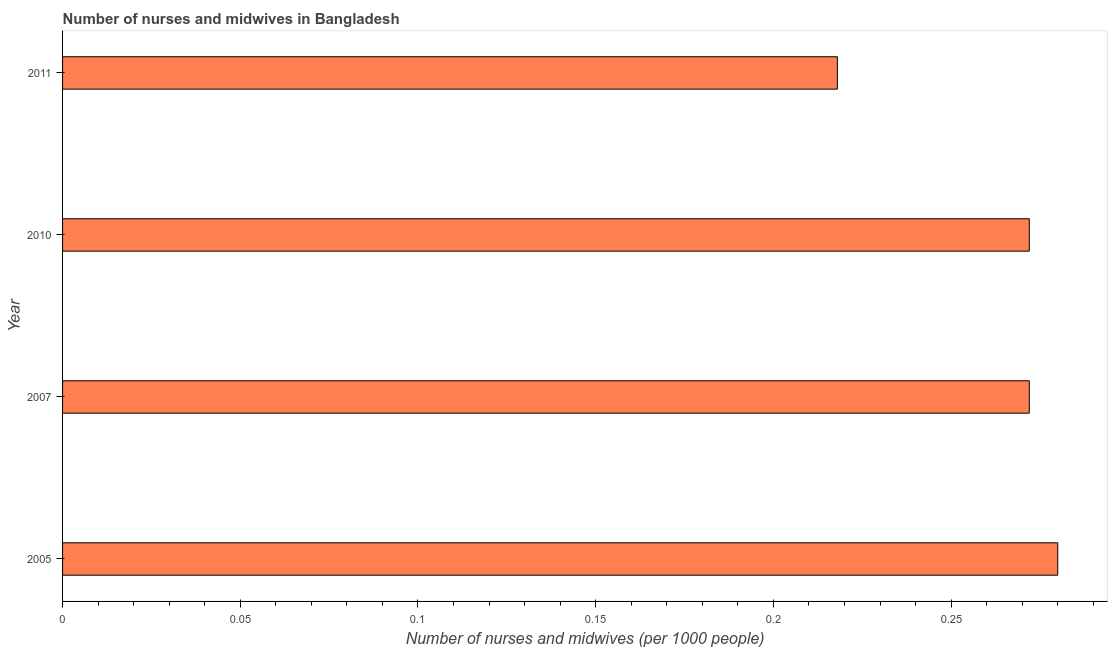Does the graph contain any zero values?
Offer a terse response. No. What is the title of the graph?
Your answer should be compact. Number of nurses and midwives in Bangladesh. What is the label or title of the X-axis?
Provide a short and direct response. Number of nurses and midwives (per 1000 people). What is the label or title of the Y-axis?
Give a very brief answer. Year. What is the number of nurses and midwives in 2007?
Your response must be concise. 0.27. Across all years, what is the maximum number of nurses and midwives?
Make the answer very short. 0.28. Across all years, what is the minimum number of nurses and midwives?
Provide a succinct answer. 0.22. In which year was the number of nurses and midwives maximum?
Give a very brief answer. 2005. In which year was the number of nurses and midwives minimum?
Make the answer very short. 2011. What is the sum of the number of nurses and midwives?
Provide a short and direct response. 1.04. What is the difference between the number of nurses and midwives in 2007 and 2011?
Provide a succinct answer. 0.05. What is the average number of nurses and midwives per year?
Ensure brevity in your answer.  0.26. What is the median number of nurses and midwives?
Make the answer very short. 0.27. In how many years, is the number of nurses and midwives greater than 0.24 ?
Make the answer very short. 3. Do a majority of the years between 2011 and 2010 (inclusive) have number of nurses and midwives greater than 0.22 ?
Offer a very short reply. No. Is the number of nurses and midwives in 2005 less than that in 2007?
Your answer should be very brief. No. Is the difference between the number of nurses and midwives in 2007 and 2010 greater than the difference between any two years?
Provide a short and direct response. No. What is the difference between the highest and the second highest number of nurses and midwives?
Your response must be concise. 0.01. What is the difference between the highest and the lowest number of nurses and midwives?
Give a very brief answer. 0.06. How many bars are there?
Your answer should be very brief. 4. What is the difference between two consecutive major ticks on the X-axis?
Ensure brevity in your answer.  0.05. What is the Number of nurses and midwives (per 1000 people) of 2005?
Offer a very short reply. 0.28. What is the Number of nurses and midwives (per 1000 people) in 2007?
Your response must be concise. 0.27. What is the Number of nurses and midwives (per 1000 people) in 2010?
Offer a terse response. 0.27. What is the Number of nurses and midwives (per 1000 people) in 2011?
Keep it short and to the point. 0.22. What is the difference between the Number of nurses and midwives (per 1000 people) in 2005 and 2007?
Keep it short and to the point. 0.01. What is the difference between the Number of nurses and midwives (per 1000 people) in 2005 and 2010?
Your response must be concise. 0.01. What is the difference between the Number of nurses and midwives (per 1000 people) in 2005 and 2011?
Ensure brevity in your answer.  0.06. What is the difference between the Number of nurses and midwives (per 1000 people) in 2007 and 2010?
Offer a very short reply. 0. What is the difference between the Number of nurses and midwives (per 1000 people) in 2007 and 2011?
Give a very brief answer. 0.05. What is the difference between the Number of nurses and midwives (per 1000 people) in 2010 and 2011?
Offer a very short reply. 0.05. What is the ratio of the Number of nurses and midwives (per 1000 people) in 2005 to that in 2007?
Your answer should be very brief. 1.03. What is the ratio of the Number of nurses and midwives (per 1000 people) in 2005 to that in 2011?
Make the answer very short. 1.28. What is the ratio of the Number of nurses and midwives (per 1000 people) in 2007 to that in 2010?
Give a very brief answer. 1. What is the ratio of the Number of nurses and midwives (per 1000 people) in 2007 to that in 2011?
Your response must be concise. 1.25. What is the ratio of the Number of nurses and midwives (per 1000 people) in 2010 to that in 2011?
Offer a terse response. 1.25. 